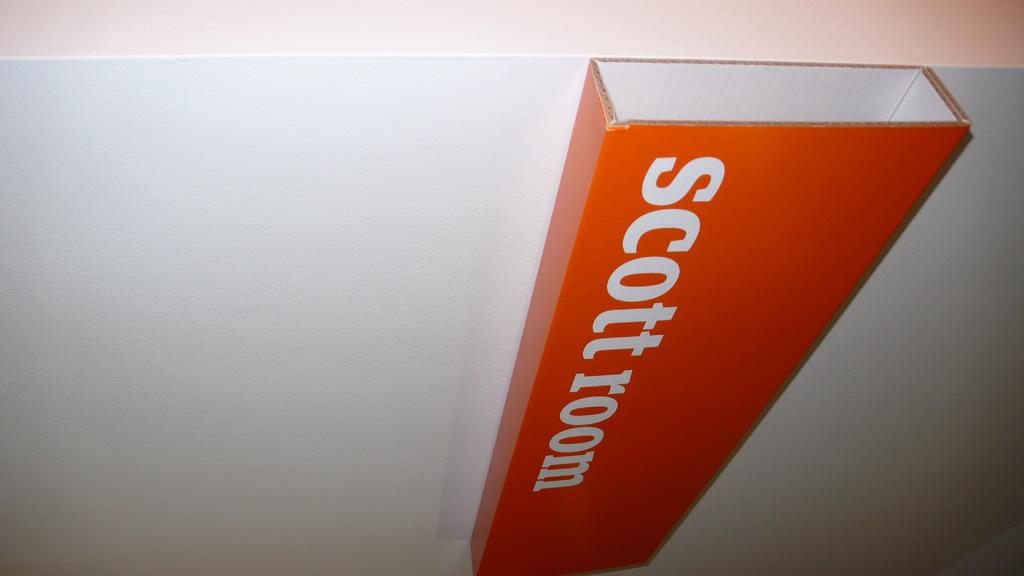<image>
Write a terse but informative summary of the picture. An orange sign hung sideways on a white wall says scott room. 